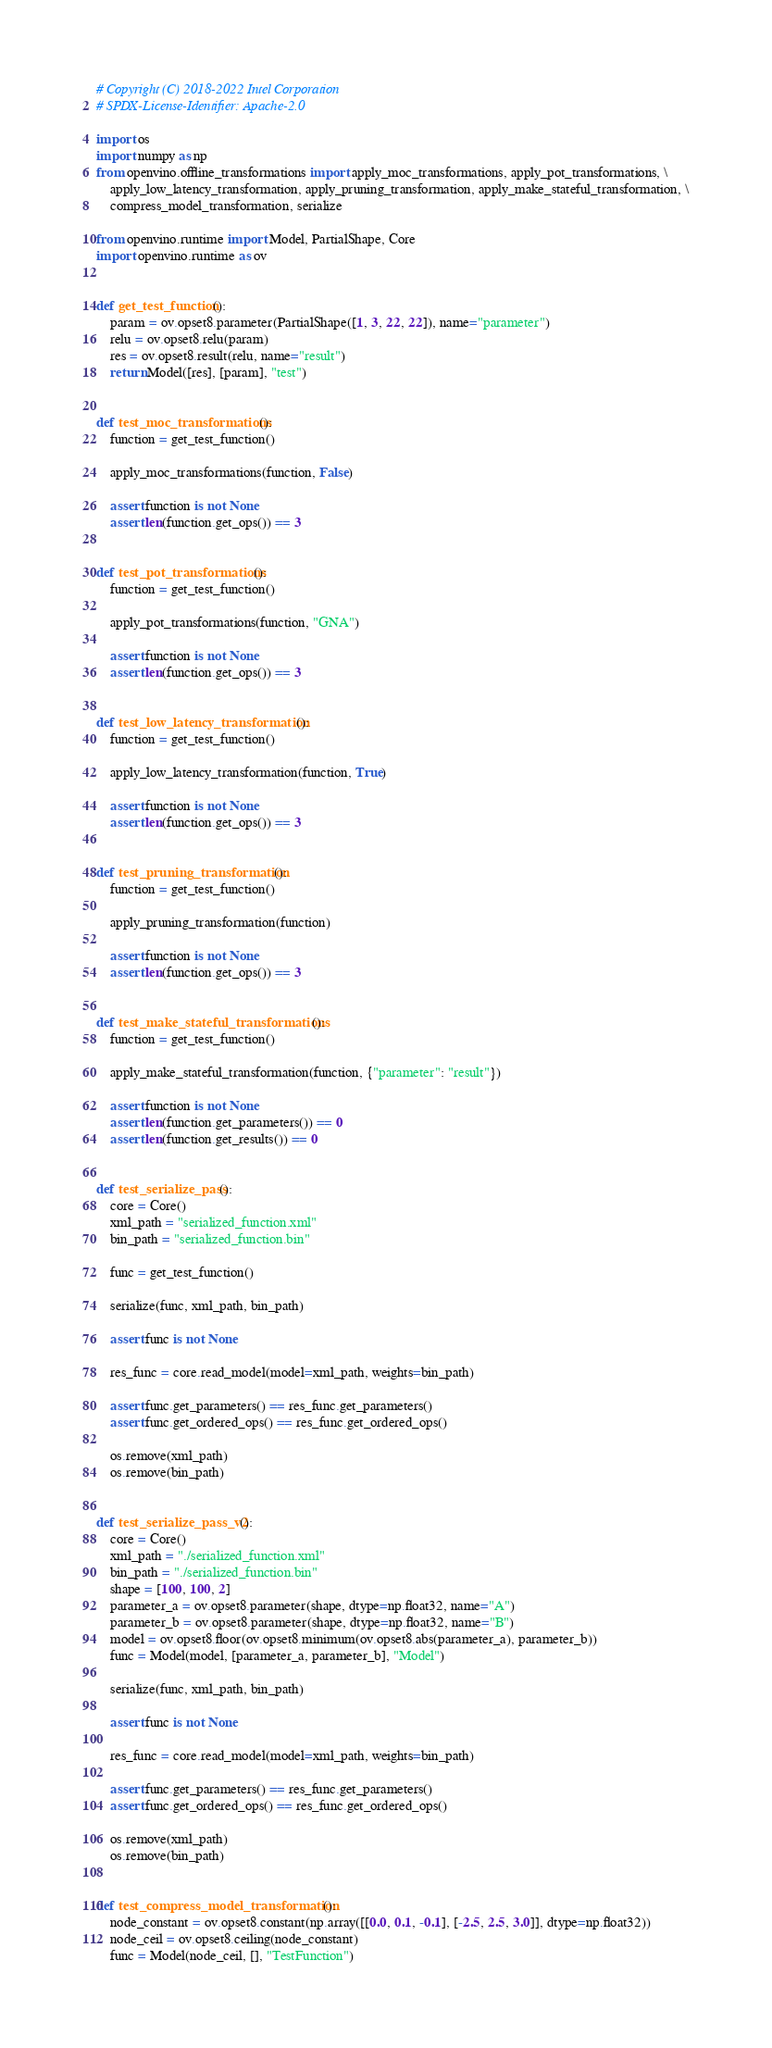<code> <loc_0><loc_0><loc_500><loc_500><_Python_># Copyright (C) 2018-2022 Intel Corporation
# SPDX-License-Identifier: Apache-2.0

import os
import numpy as np
from openvino.offline_transformations import apply_moc_transformations, apply_pot_transformations, \
    apply_low_latency_transformation, apply_pruning_transformation, apply_make_stateful_transformation, \
    compress_model_transformation, serialize

from openvino.runtime import Model, PartialShape, Core
import openvino.runtime as ov


def get_test_function():
    param = ov.opset8.parameter(PartialShape([1, 3, 22, 22]), name="parameter")
    relu = ov.opset8.relu(param)
    res = ov.opset8.result(relu, name="result")
    return Model([res], [param], "test")


def test_moc_transformations():
    function = get_test_function()

    apply_moc_transformations(function, False)

    assert function is not None
    assert len(function.get_ops()) == 3


def test_pot_transformations():
    function = get_test_function()

    apply_pot_transformations(function, "GNA")

    assert function is not None
    assert len(function.get_ops()) == 3


def test_low_latency_transformation():
    function = get_test_function()

    apply_low_latency_transformation(function, True)

    assert function is not None
    assert len(function.get_ops()) == 3


def test_pruning_transformation():
    function = get_test_function()

    apply_pruning_transformation(function)

    assert function is not None
    assert len(function.get_ops()) == 3


def test_make_stateful_transformations():
    function = get_test_function()

    apply_make_stateful_transformation(function, {"parameter": "result"})

    assert function is not None
    assert len(function.get_parameters()) == 0
    assert len(function.get_results()) == 0


def test_serialize_pass():
    core = Core()
    xml_path = "serialized_function.xml"
    bin_path = "serialized_function.bin"

    func = get_test_function()

    serialize(func, xml_path, bin_path)

    assert func is not None

    res_func = core.read_model(model=xml_path, weights=bin_path)

    assert func.get_parameters() == res_func.get_parameters()
    assert func.get_ordered_ops() == res_func.get_ordered_ops()

    os.remove(xml_path)
    os.remove(bin_path)


def test_serialize_pass_v2():
    core = Core()
    xml_path = "./serialized_function.xml"
    bin_path = "./serialized_function.bin"
    shape = [100, 100, 2]
    parameter_a = ov.opset8.parameter(shape, dtype=np.float32, name="A")
    parameter_b = ov.opset8.parameter(shape, dtype=np.float32, name="B")
    model = ov.opset8.floor(ov.opset8.minimum(ov.opset8.abs(parameter_a), parameter_b))
    func = Model(model, [parameter_a, parameter_b], "Model")

    serialize(func, xml_path, bin_path)

    assert func is not None

    res_func = core.read_model(model=xml_path, weights=bin_path)

    assert func.get_parameters() == res_func.get_parameters()
    assert func.get_ordered_ops() == res_func.get_ordered_ops()

    os.remove(xml_path)
    os.remove(bin_path)


def test_compress_model_transformation():
    node_constant = ov.opset8.constant(np.array([[0.0, 0.1, -0.1], [-2.5, 2.5, 3.0]], dtype=np.float32))
    node_ceil = ov.opset8.ceiling(node_constant)
    func = Model(node_ceil, [], "TestFunction")</code> 